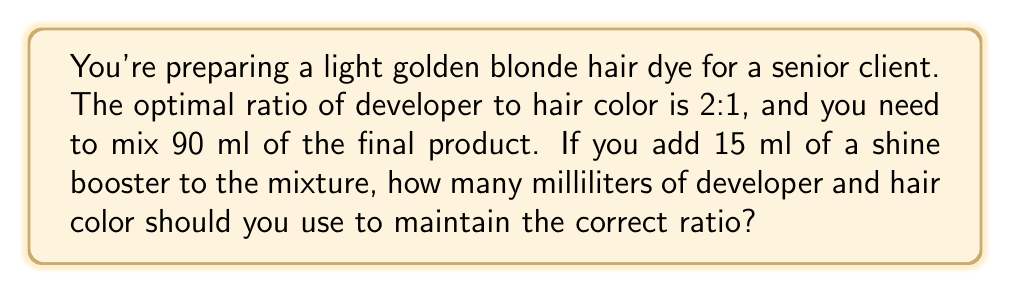Can you answer this question? Let's approach this step-by-step:

1) First, we need to determine the total volume of developer and hair color:
   $90 \text{ ml} - 15 \text{ ml} = 75 \text{ ml}$

2) We know the ratio of developer to hair color is 2:1. Let's represent this mathematically:
   Let $x$ be the amount of hair color.
   Then $2x$ will be the amount of developer.

3) We can set up an equation:
   $x + 2x = 75$
   $3x = 75$

4) Solve for $x$:
   $x = 75 \div 3 = 25$

5) So, the amount of hair color is 25 ml.

6) The amount of developer is $2x = 2(25) = 50$ ml.

7) Let's verify:
   $25 \text{ ml (hair color)} + 50 \text{ ml (developer)} + 15 \text{ ml (shine booster)} = 90 \text{ ml (total)}$

8) Check the ratio:
   $\frac{\text{developer}}{\text{hair color}} = \frac{50}{25} = 2:1$

Therefore, you should use 50 ml of developer and 25 ml of hair color.
Answer: 50 ml of developer and 25 ml of hair color 